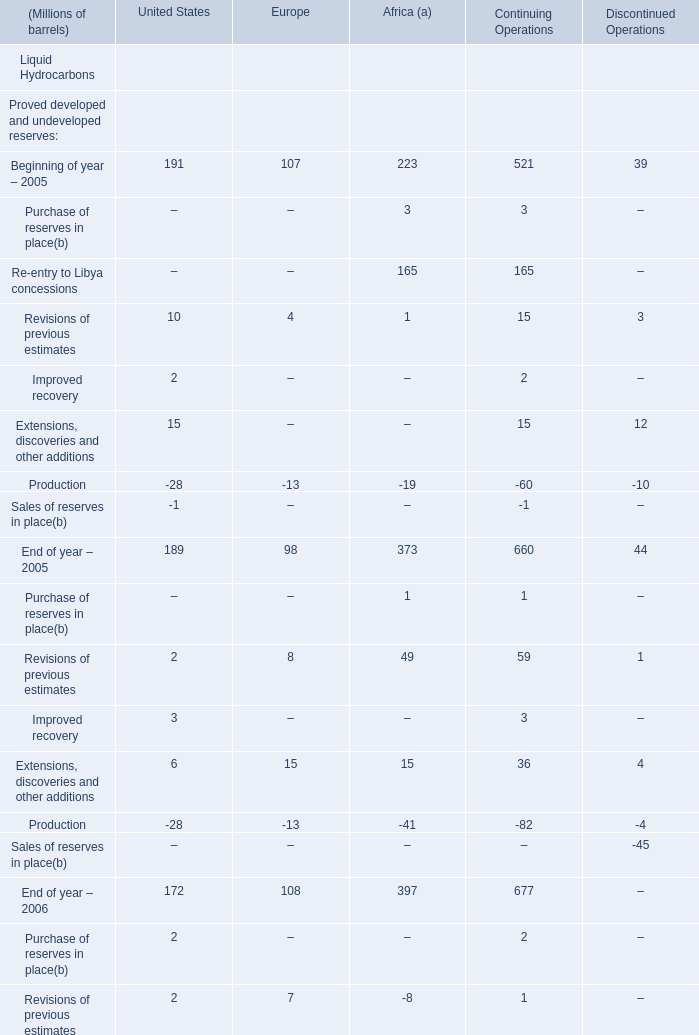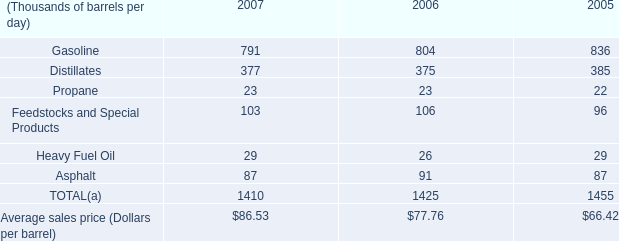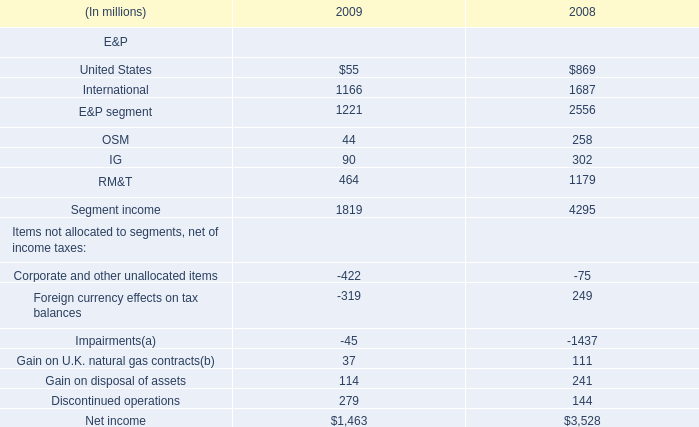What is the total value of Extensions, discoveries and other additions , Production, End of year – 2006 and Sales of reserves in place for Africa (a)? (in Million) 
Computations: (((15 - 41) + 0) + 397)
Answer: 371.0. 